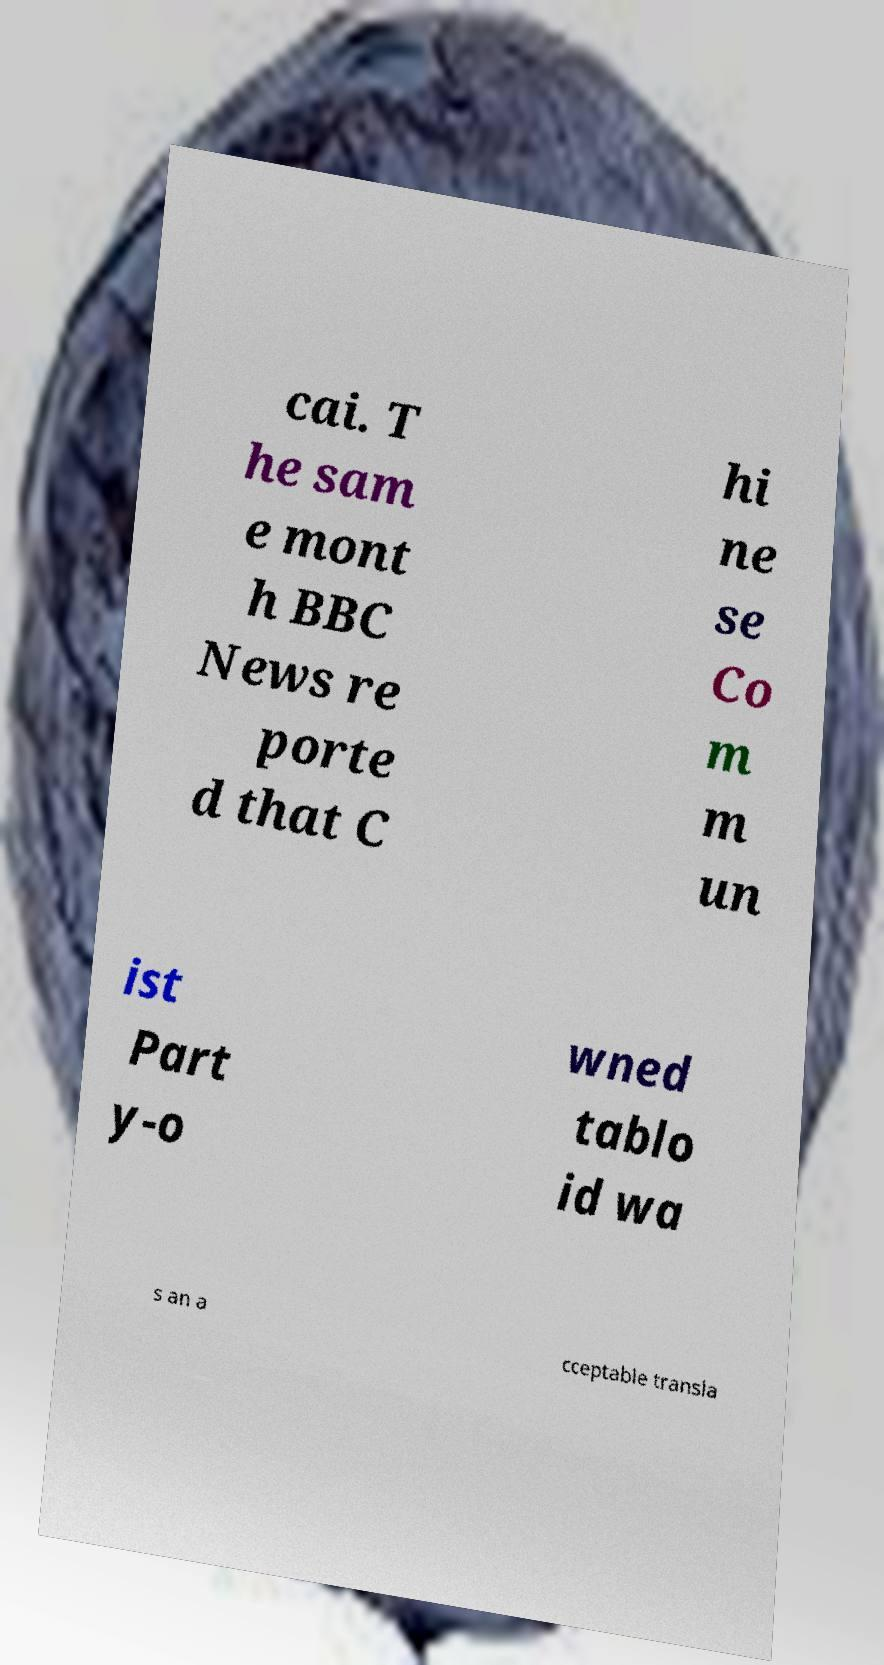For documentation purposes, I need the text within this image transcribed. Could you provide that? cai. T he sam e mont h BBC News re porte d that C hi ne se Co m m un ist Part y-o wned tablo id wa s an a cceptable transla 